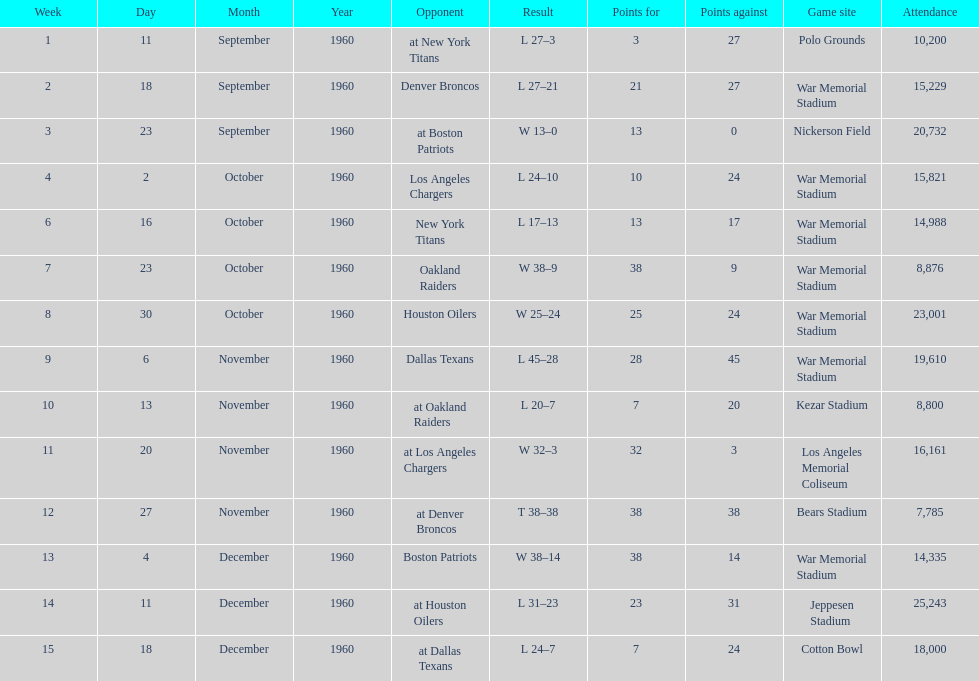How many games had at least 10,000 people in attendance? 11. Parse the table in full. {'header': ['Week', 'Day', 'Month', 'Year', 'Opponent', 'Result', 'Points for', 'Points against', 'Game site', 'Attendance'], 'rows': [['1', '11', 'September', '1960', 'at New York Titans', 'L 27–3', '3', '27', 'Polo Grounds', '10,200'], ['2', '18', 'September', '1960', 'Denver Broncos', 'L 27–21', '21', '27', 'War Memorial Stadium', '15,229'], ['3', '23', 'September', '1960', 'at Boston Patriots', 'W 13–0', '13', '0', 'Nickerson Field', '20,732'], ['4', '2', 'October', '1960', 'Los Angeles Chargers', 'L 24–10', '10', '24', 'War Memorial Stadium', '15,821'], ['6', '16', 'October', '1960', 'New York Titans', 'L 17–13', '13', '17', 'War Memorial Stadium', '14,988'], ['7', '23', 'October', '1960', 'Oakland Raiders', 'W 38–9', '38', '9', 'War Memorial Stadium', '8,876'], ['8', '30', 'October', '1960', 'Houston Oilers', 'W 25–24', '25', '24', 'War Memorial Stadium', '23,001'], ['9', '6', 'November', '1960', 'Dallas Texans', 'L 45–28', '28', '45', 'War Memorial Stadium', '19,610'], ['10', '13', 'November', '1960', 'at Oakland Raiders', 'L 20–7', '7', '20', 'Kezar Stadium', '8,800'], ['11', '20', 'November', '1960', 'at Los Angeles Chargers', 'W 32–3', '32', '3', 'Los Angeles Memorial Coliseum', '16,161'], ['12', '27', 'November', '1960', 'at Denver Broncos', 'T 38–38', '38', '38', 'Bears Stadium', '7,785'], ['13', '4', 'December', '1960', 'Boston Patriots', 'W 38–14', '38', '14', 'War Memorial Stadium', '14,335'], ['14', '11', 'December', '1960', 'at Houston Oilers', 'L 31–23', '23', '31', 'Jeppesen Stadium', '25,243'], ['15', '18', 'December', '1960', 'at Dallas Texans', 'L 24–7', '7', '24', 'Cotton Bowl', '18,000']]} 